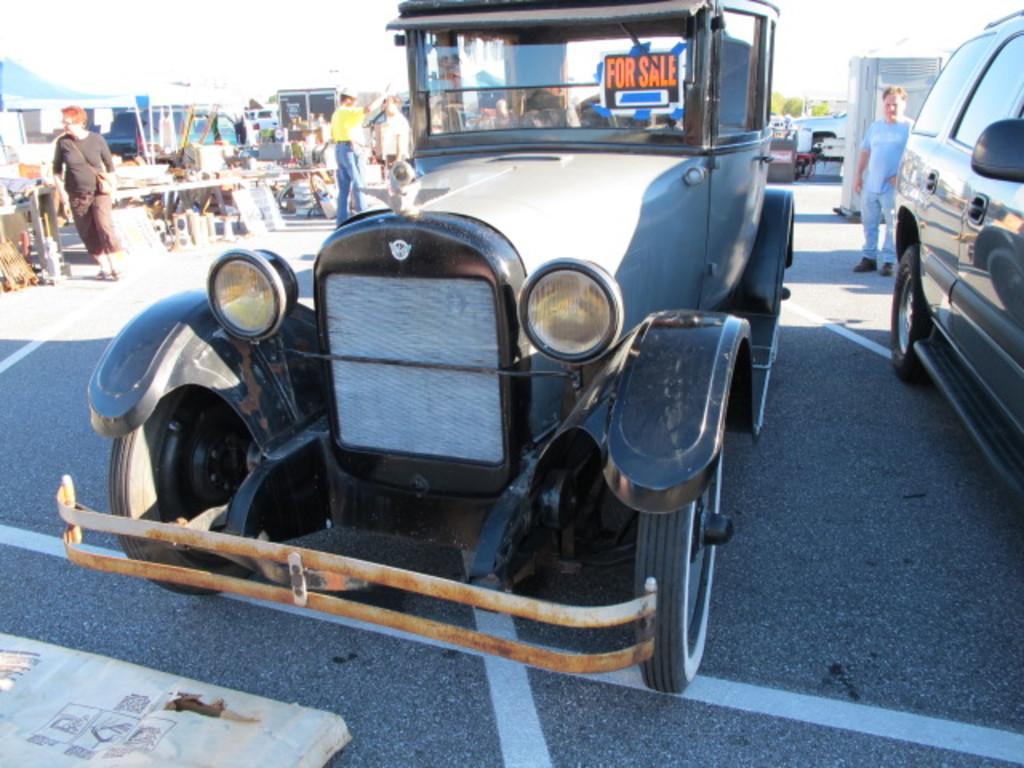What can be seen in the image related to transportation? There are cars parked in the image. What else can be seen in the background of the image? There are people standing in the background of the image. What objects are placed on tables in the image? The specific objects placed on tables are not mentioned, but there are objects present on tables in the image. Can you tell me how many yaks are grazing in the image? There are no yaks present in the image. What type of property is visible in the image? The specific type of property is not mentioned, but there are parked cars and people standing in the image. 